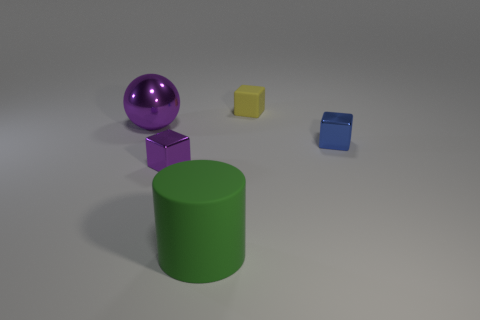Subtract all small purple shiny cubes. How many cubes are left? 2 Subtract 1 purple balls. How many objects are left? 4 Subtract all cylinders. How many objects are left? 4 Subtract 1 cylinders. How many cylinders are left? 0 Subtract all green spheres. Subtract all red cylinders. How many spheres are left? 1 Subtract all blue cylinders. How many blue cubes are left? 1 Subtract all green rubber cylinders. Subtract all small yellow things. How many objects are left? 3 Add 5 yellow cubes. How many yellow cubes are left? 6 Add 1 matte blocks. How many matte blocks exist? 2 Add 1 large green rubber cylinders. How many objects exist? 6 